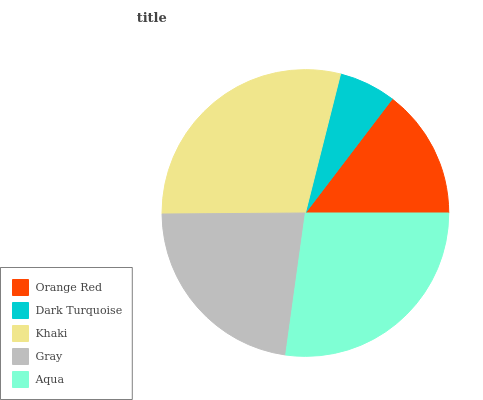Is Dark Turquoise the minimum?
Answer yes or no. Yes. Is Khaki the maximum?
Answer yes or no. Yes. Is Khaki the minimum?
Answer yes or no. No. Is Dark Turquoise the maximum?
Answer yes or no. No. Is Khaki greater than Dark Turquoise?
Answer yes or no. Yes. Is Dark Turquoise less than Khaki?
Answer yes or no. Yes. Is Dark Turquoise greater than Khaki?
Answer yes or no. No. Is Khaki less than Dark Turquoise?
Answer yes or no. No. Is Gray the high median?
Answer yes or no. Yes. Is Gray the low median?
Answer yes or no. Yes. Is Khaki the high median?
Answer yes or no. No. Is Dark Turquoise the low median?
Answer yes or no. No. 